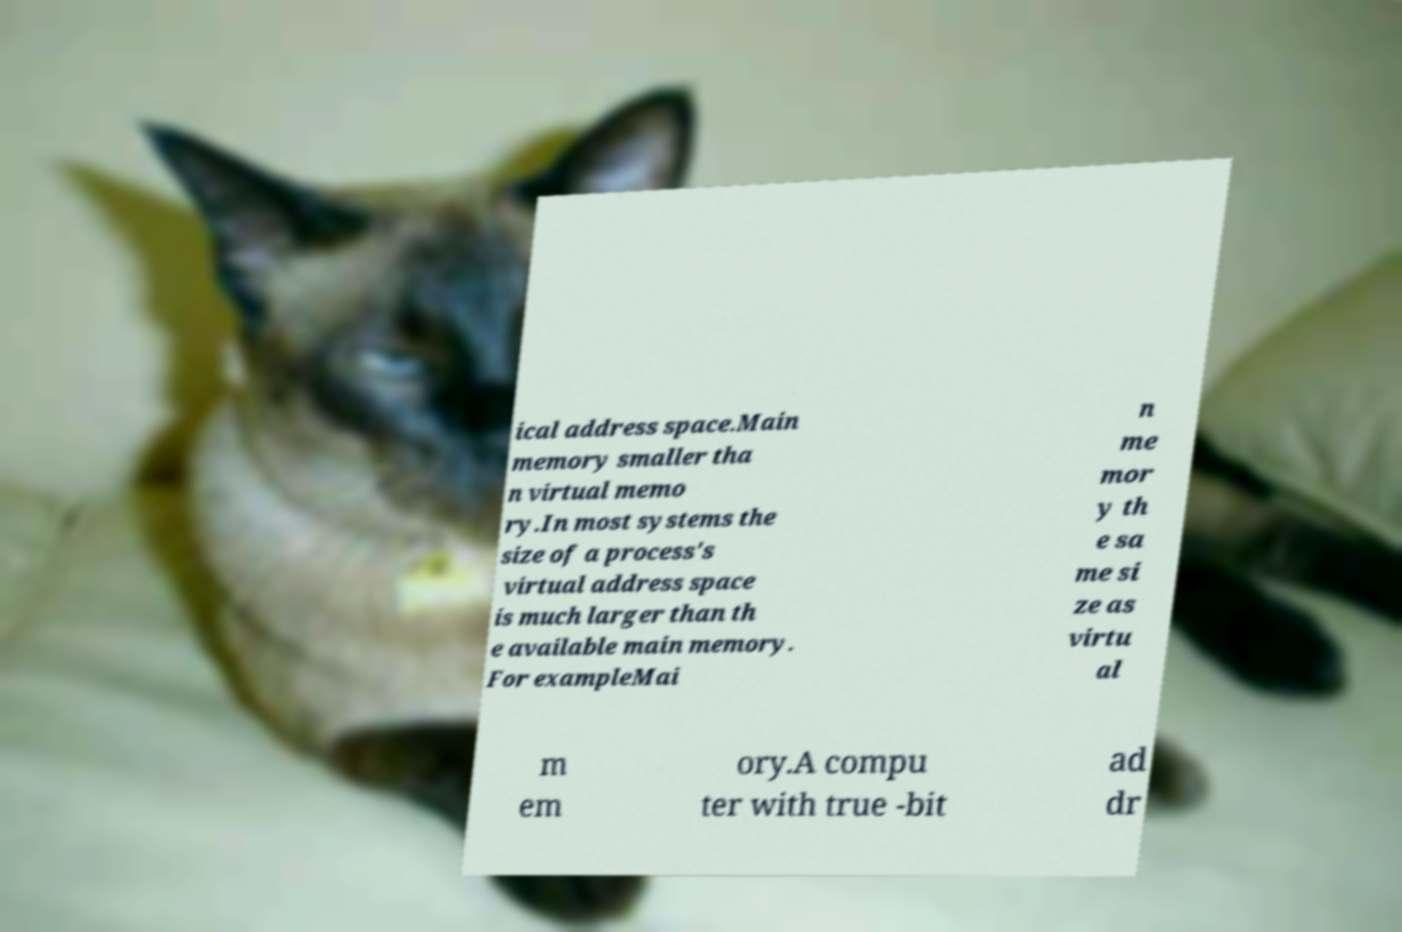There's text embedded in this image that I need extracted. Can you transcribe it verbatim? ical address space.Main memory smaller tha n virtual memo ry.In most systems the size of a process's virtual address space is much larger than th e available main memory. For exampleMai n me mor y th e sa me si ze as virtu al m em ory.A compu ter with true -bit ad dr 